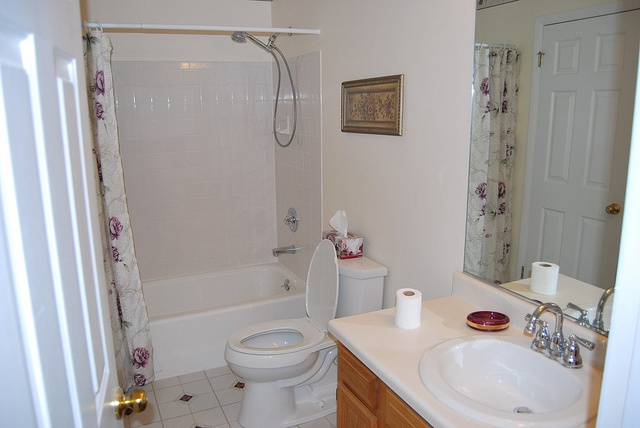Describe the objects in this image and their specific colors. I can see sink in darkgray and lightgray tones and toilet in darkgray and gray tones in this image. 